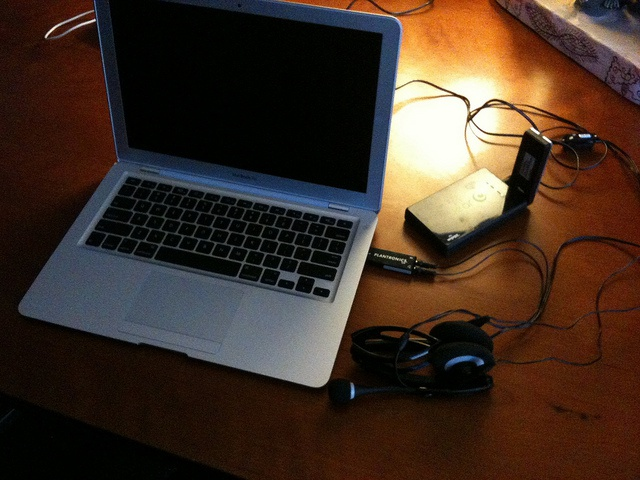Describe the objects in this image and their specific colors. I can see laptop in black, gray, darkblue, and navy tones and cell phone in black, khaki, lightyellow, and tan tones in this image. 